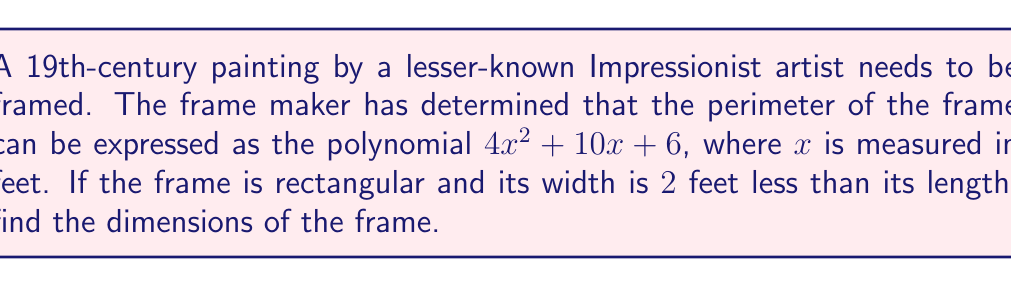Solve this math problem. Let's approach this step-by-step:

1) Let the length of the frame be $l$ and the width be $w$.

2) We're told that the width is 2 feet less than the length, so we can express $w$ in terms of $l$:
   $w = l - 2$

3) The perimeter of a rectangle is given by the formula $2l + 2w$. We're told this equals $4x^2 + 10x + 6$:
   $2l + 2w = 4x^2 + 10x + 6$

4) Substituting $w = l - 2$ into this equation:
   $2l + 2(l - 2) = 4x^2 + 10x + 6$

5) Simplifying:
   $2l + 2l - 4 = 4x^2 + 10x + 6$
   $4l - 4 = 4x^2 + 10x + 6$

6) Adding 4 to both sides:
   $4l = 4x^2 + 10x + 10$

7) Dividing by 4:
   $l = x^2 + \frac{5}{2}x + \frac{5}{2}$

8) Remember, $w = l - 2$, so:
   $w = (x^2 + \frac{5}{2}x + \frac{5}{2}) - 2 = x^2 + \frac{5}{2}x + \frac{1}{2}$

9) Now we have expressions for both $l$ and $w$ in terms of $x$. These are the dimensions of the frame.
Answer: Length: $l = x^2 + \frac{5}{2}x + \frac{5}{2}$, Width: $w = x^2 + \frac{5}{2}x + \frac{1}{2}$ 